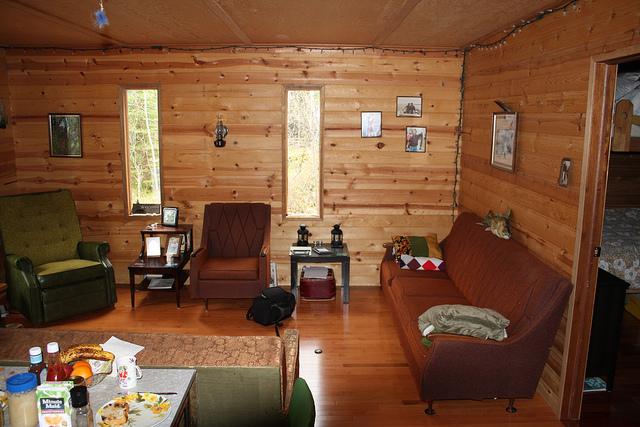Is there fruit on the table on the left?
Short answer required. Yes. How many windows are in the room?
Give a very brief answer. 2. Would this room be considered rustic?
Quick response, please. Yes. 